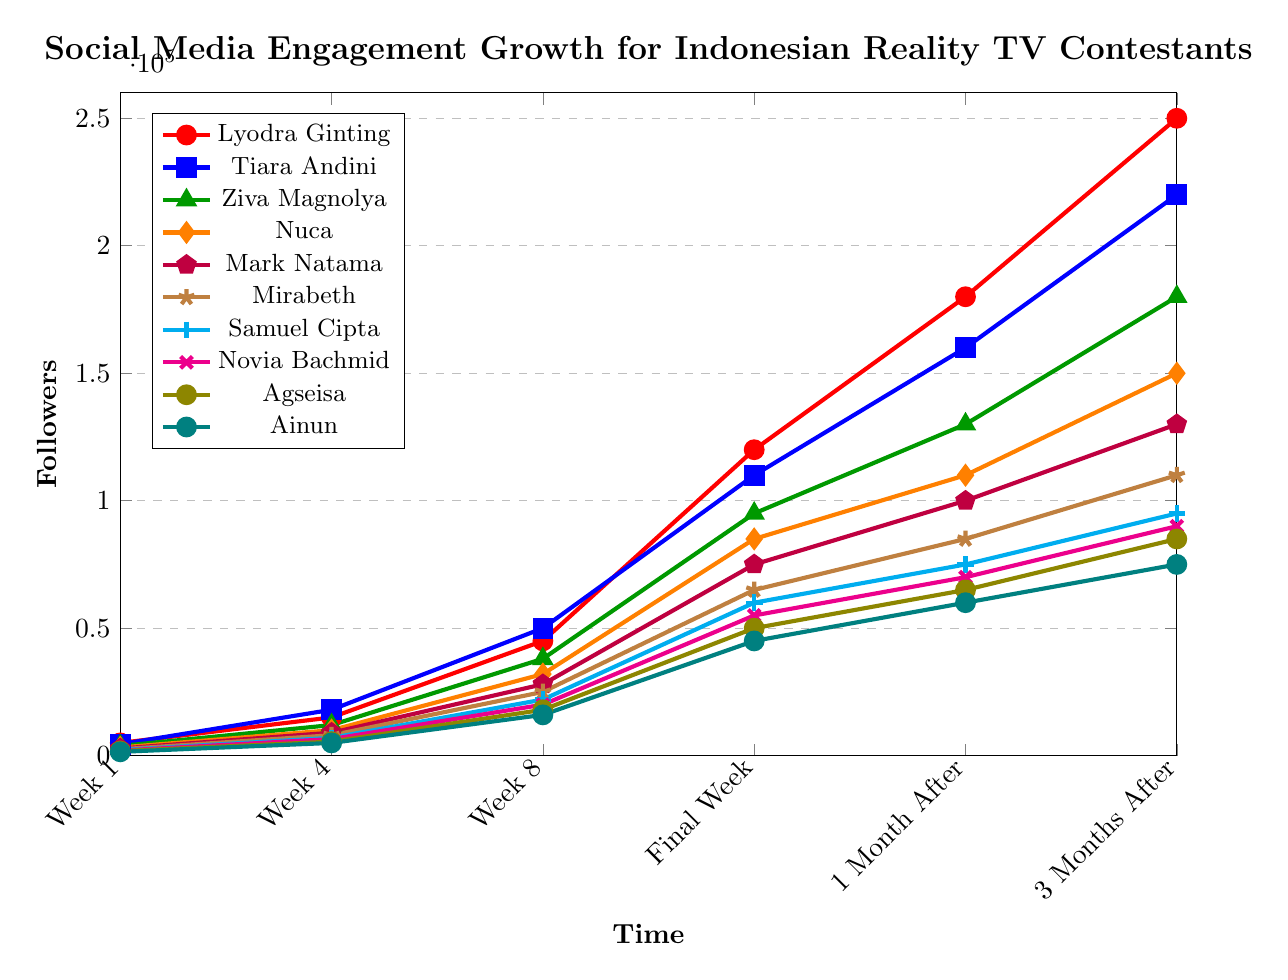Which contestant had the highest social media engagement in the final week? Lyodra Ginting had the highest social media engagement in the final week with 120,000 followers.
Answer: Lyodra Ginting How much did Ziva Magnolya’s followers increase from Week 1 to 3 months after? To find the increase, subtract the Week 1 value from the 3 Months After value: 180,000 - 3,800 = 176,200.
Answer: 176,200 Who had more followers 1 month after the final week, Nuca or Mark Natama? Nuca had 110,000 followers 1 month after, while Mark Natama had 100,000. Thus, Nuca had more followers.
Answer: Nuca Whose followers grew the fastest in the final week compared to Week 8? To find the growth, the formula used is (Final Week - Week 8). For Lyodra Ginting, the followers increased from 45,000 to 120,000. The difference is 120,000 - 45,000 = 75,000, which is the highest compared to other contestants.
Answer: Lyodra Ginting What's the difference in followers between Tiara Andini and Samuel Cipta 3 months after the season? Tiara Andini had 220,000 followers and Samuel Cipta had 95,000. The difference is 220,000 - 95,000 = 125,000.
Answer: 125,000 Which contestant had the lowest engagement in Week 4? According to the plot, Ainun had the lowest engagement in Week 4 with 5,000 followers.
Answer: Ainun Between Week 4, Week 8, and the final week, which period saw the highest growth rate for Lyodra Ginting? The growth rates are:
- Week1 to Week4: 15,000 - 5,000 = 10,000
- Week4 to Week8: 45,000 - 15,000 = 30,000
- Week8 to Final Week: 120,000 - 45,000 = 75,000
The highest growth rate occurred between Week 8 and the final week.
Answer: Week8 to Final Week In the final week, who had fewer followers, Mirabeth or Samuel Cipta? Mirabeth had 65,000 followers and Samuel Cipta had 60,000 in the final week. Samuel Cipta had fewer followers.
Answer: Samuel Cipta 